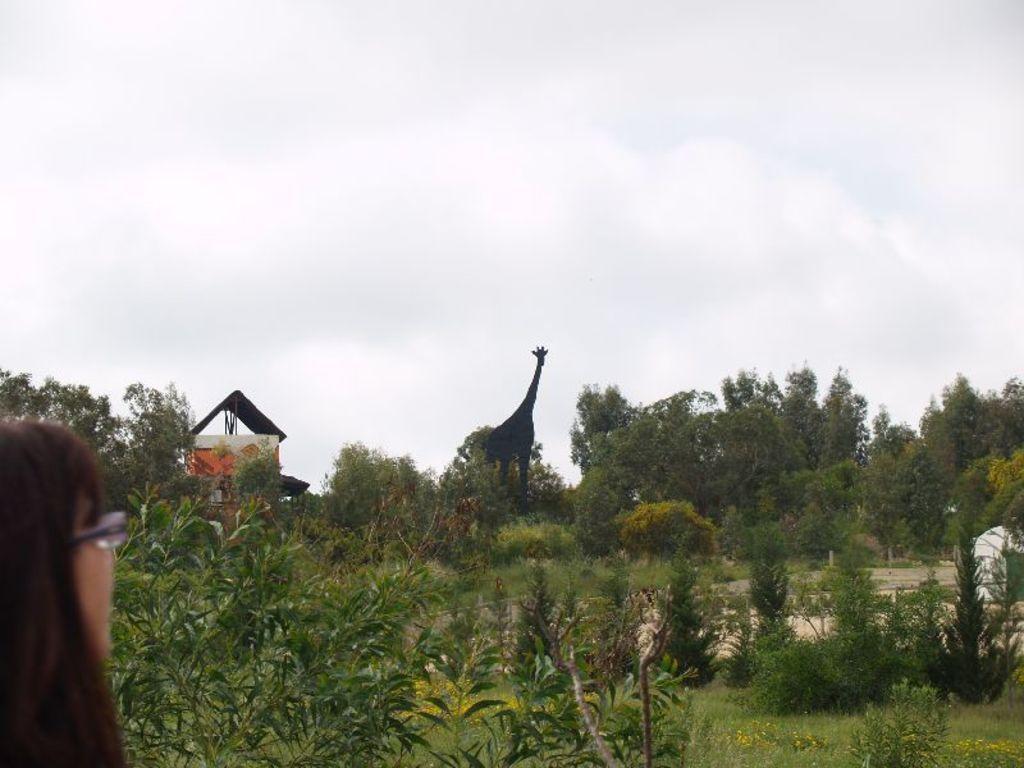Please provide a concise description of this image. In this image there is a person with spectacles, there are plants , grass, a house, trees, a giraffe , and in the background there is sky. 